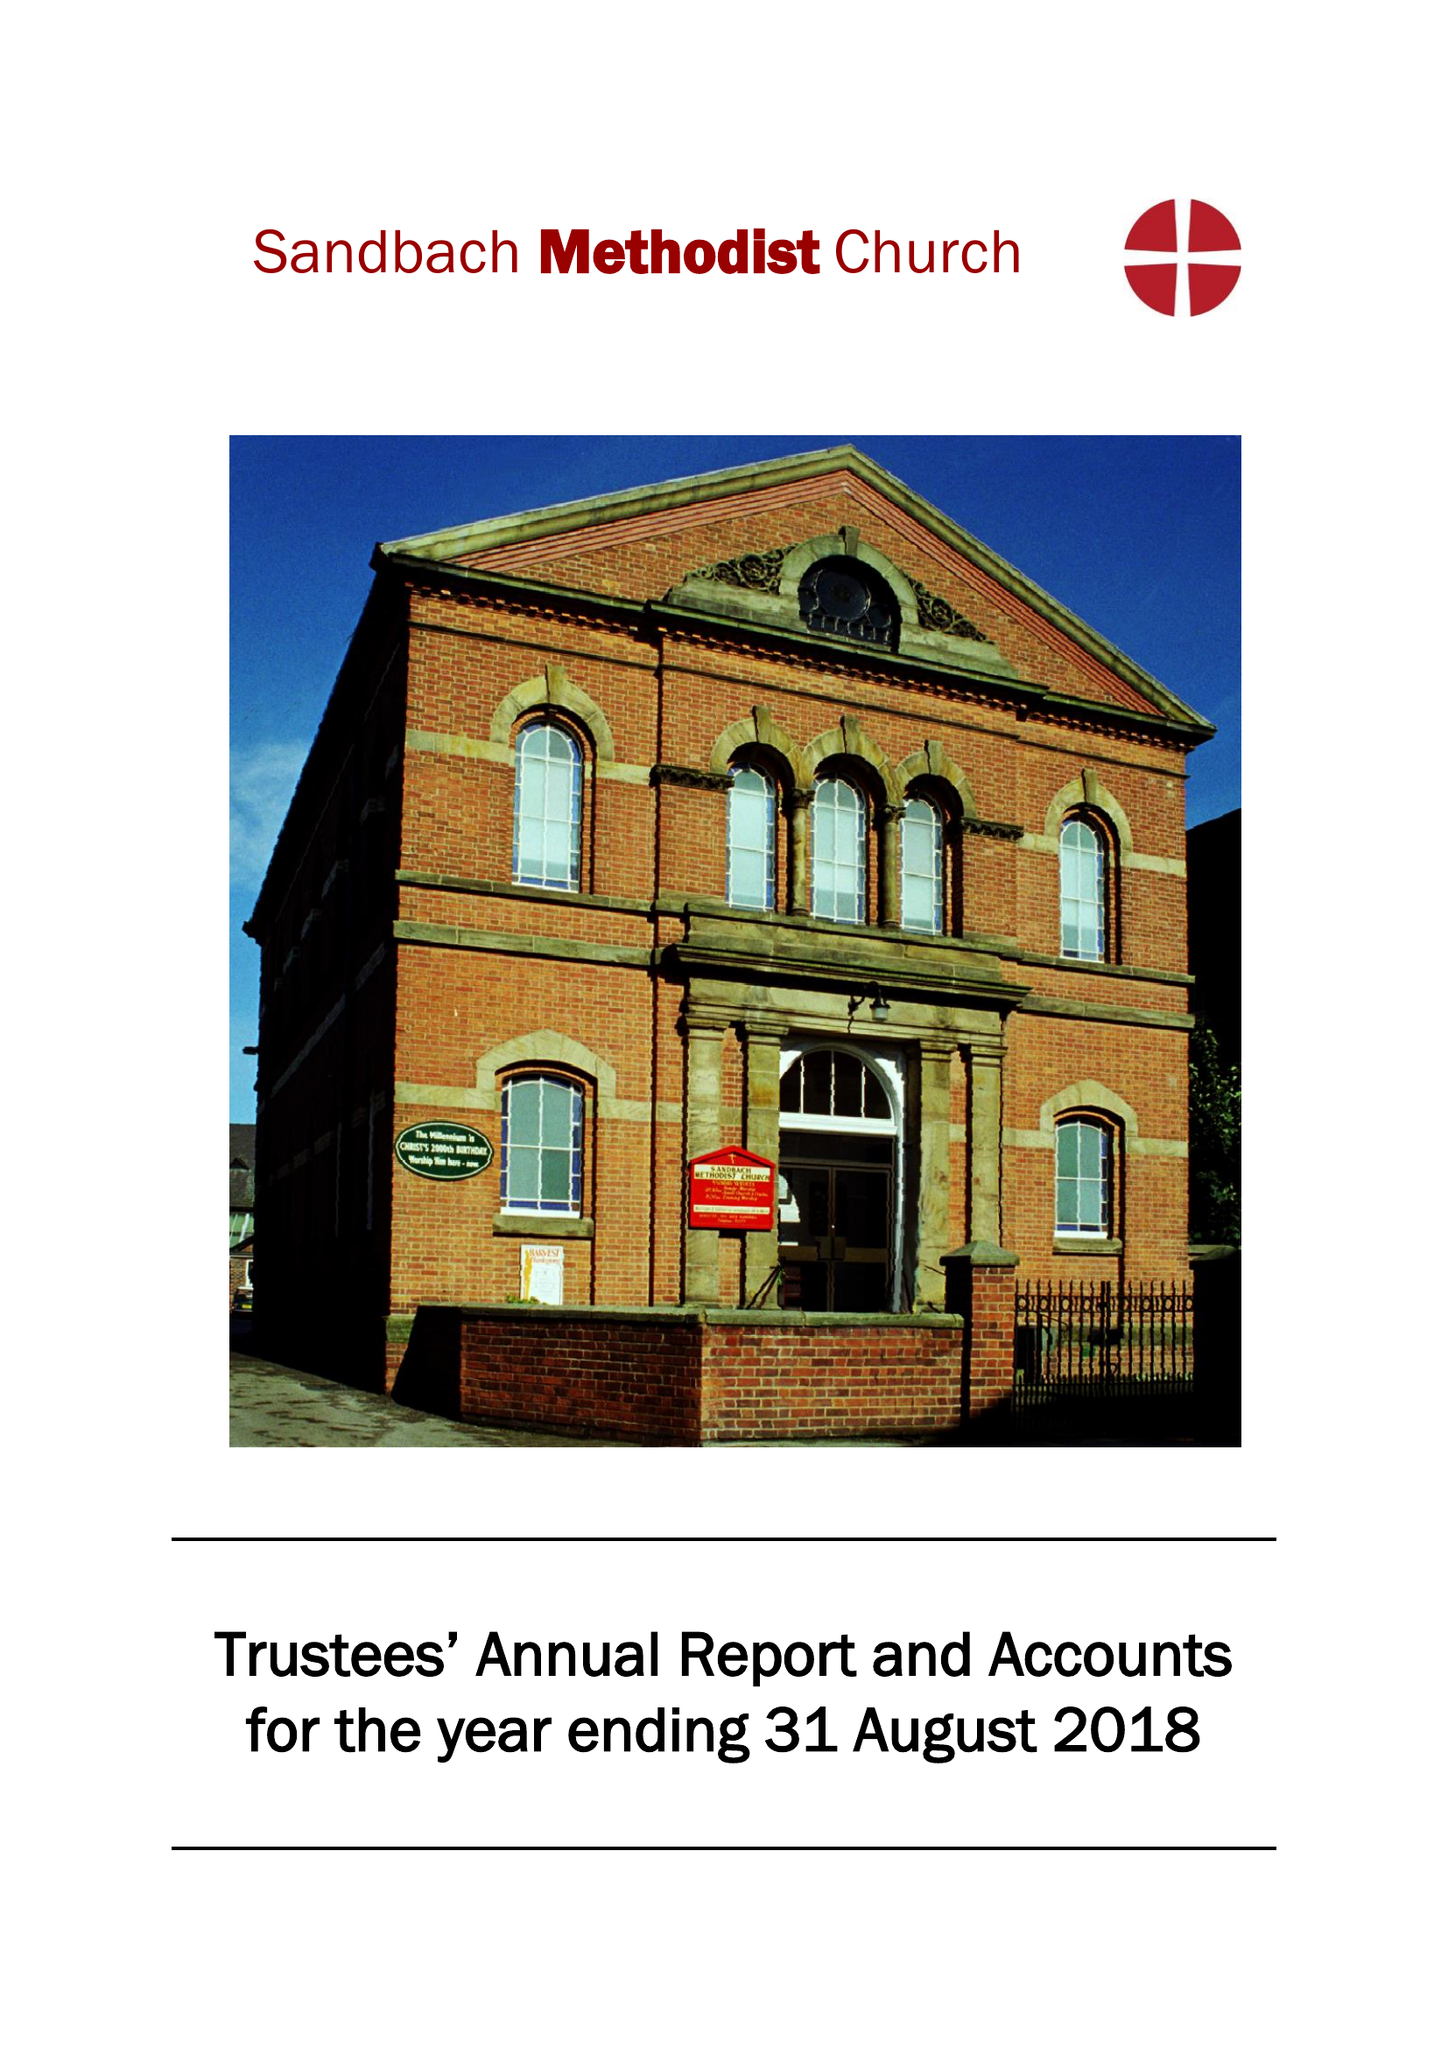What is the value for the spending_annually_in_british_pounds?
Answer the question using a single word or phrase. 88002.00 